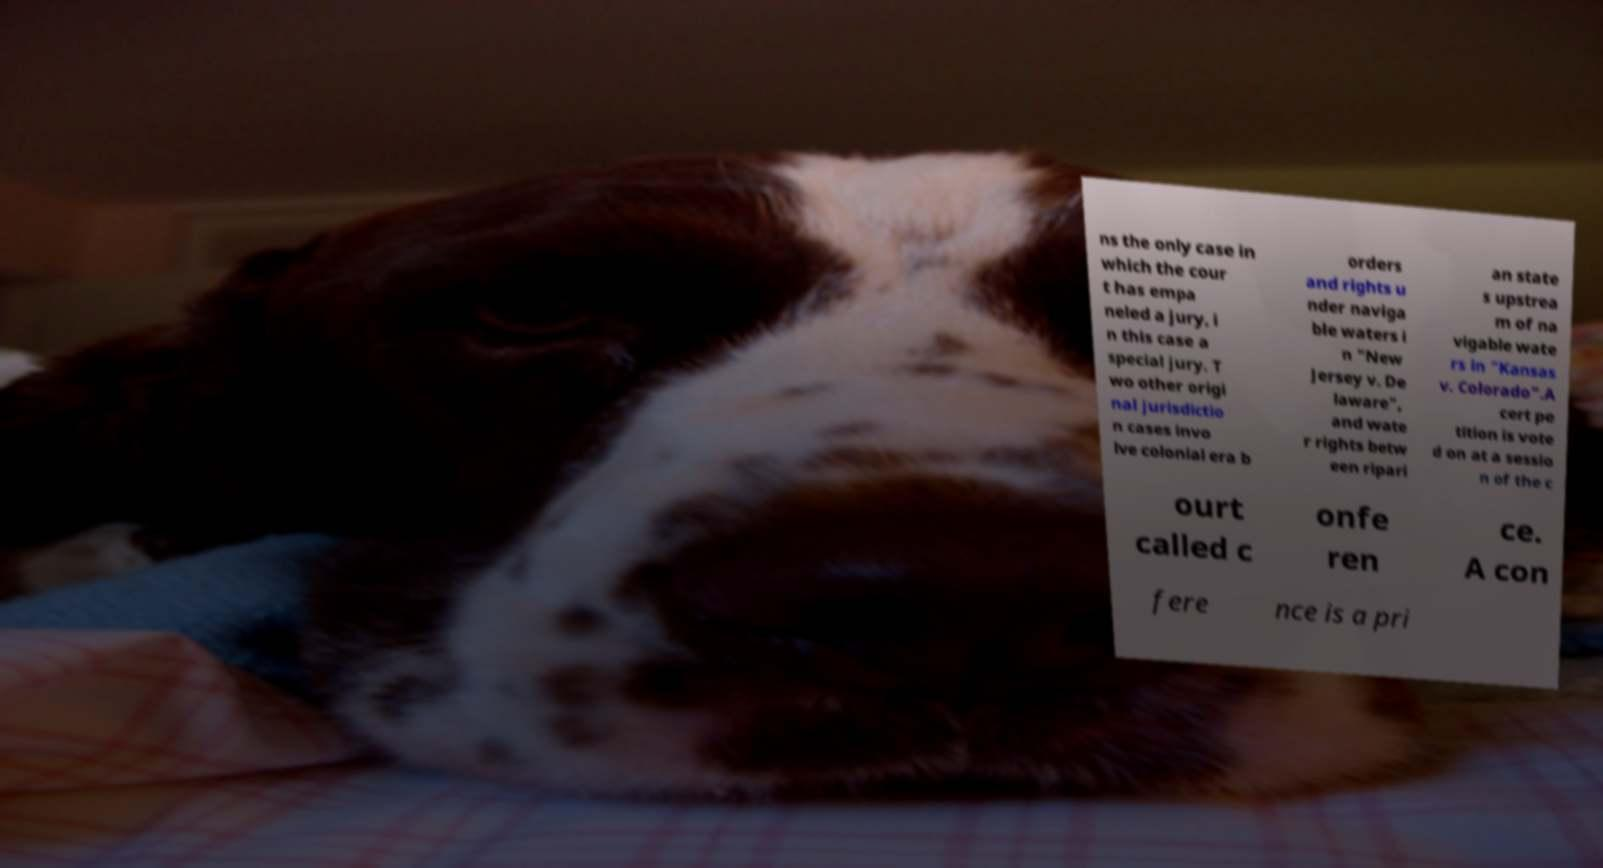Please identify and transcribe the text found in this image. ns the only case in which the cour t has empa neled a jury, i n this case a special jury. T wo other origi nal jurisdictio n cases invo lve colonial era b orders and rights u nder naviga ble waters i n "New Jersey v. De laware", and wate r rights betw een ripari an state s upstrea m of na vigable wate rs in "Kansas v. Colorado".A cert pe tition is vote d on at a sessio n of the c ourt called c onfe ren ce. A con fere nce is a pri 